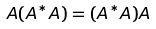Convert formula to latex. <formula><loc_0><loc_0><loc_500><loc_500>A ( A ^ { * } A ) = ( A ^ { * } A ) A</formula> 